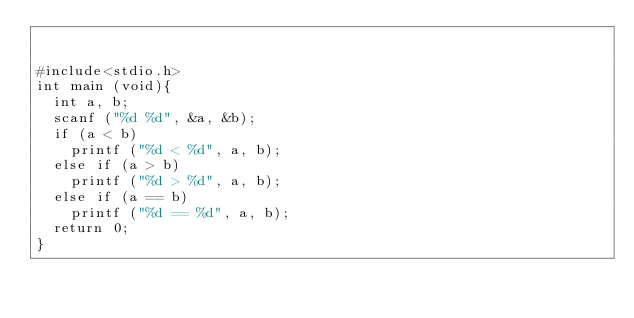<code> <loc_0><loc_0><loc_500><loc_500><_C_>

#include<stdio.h>
int main (void){
  int a, b;
  scanf ("%d %d", &a, &b);
  if (a < b)
    printf ("%d < %d", a, b);
  else if (a > b)
    printf ("%d > %d", a, b);
  else if (a == b)
    printf ("%d == %d", a, b);
  return 0;
}

 </code> 